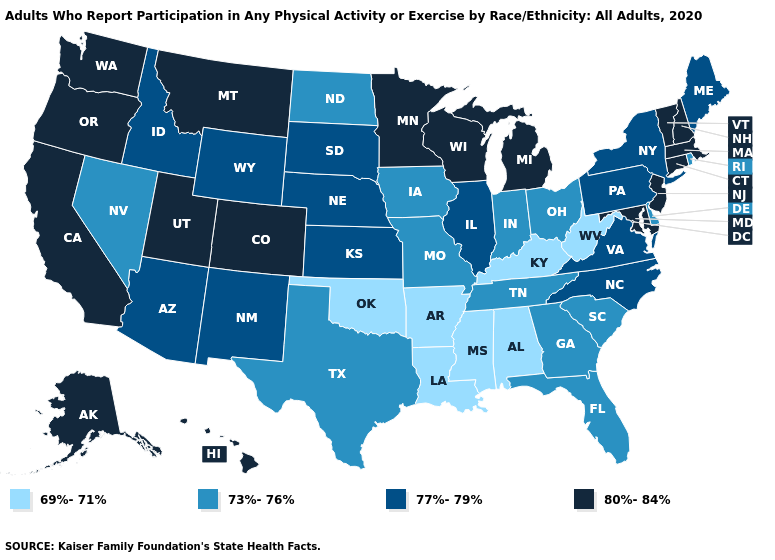What is the value of California?
Short answer required. 80%-84%. What is the value of Maine?
Quick response, please. 77%-79%. Name the states that have a value in the range 73%-76%?
Write a very short answer. Delaware, Florida, Georgia, Indiana, Iowa, Missouri, Nevada, North Dakota, Ohio, Rhode Island, South Carolina, Tennessee, Texas. Does the first symbol in the legend represent the smallest category?
Short answer required. Yes. Does Rhode Island have the highest value in the Northeast?
Keep it brief. No. Which states hav the highest value in the MidWest?
Be succinct. Michigan, Minnesota, Wisconsin. Is the legend a continuous bar?
Short answer required. No. Name the states that have a value in the range 69%-71%?
Answer briefly. Alabama, Arkansas, Kentucky, Louisiana, Mississippi, Oklahoma, West Virginia. What is the highest value in states that border Connecticut?
Concise answer only. 80%-84%. Name the states that have a value in the range 73%-76%?
Give a very brief answer. Delaware, Florida, Georgia, Indiana, Iowa, Missouri, Nevada, North Dakota, Ohio, Rhode Island, South Carolina, Tennessee, Texas. Name the states that have a value in the range 73%-76%?
Quick response, please. Delaware, Florida, Georgia, Indiana, Iowa, Missouri, Nevada, North Dakota, Ohio, Rhode Island, South Carolina, Tennessee, Texas. Which states have the highest value in the USA?
Keep it brief. Alaska, California, Colorado, Connecticut, Hawaii, Maryland, Massachusetts, Michigan, Minnesota, Montana, New Hampshire, New Jersey, Oregon, Utah, Vermont, Washington, Wisconsin. What is the value of Nevada?
Be succinct. 73%-76%. Does Louisiana have the lowest value in the USA?
Short answer required. Yes. Does Georgia have the same value as Montana?
Short answer required. No. 